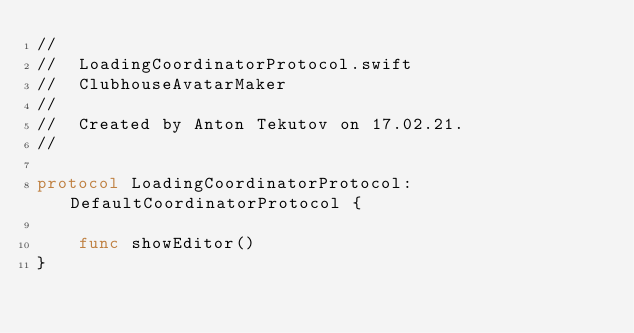Convert code to text. <code><loc_0><loc_0><loc_500><loc_500><_Swift_>//
//  LoadingCoordinatorProtocol.swift
//  ClubhouseAvatarMaker
//
//  Created by Anton Tekutov on 17.02.21.
//

protocol LoadingCoordinatorProtocol: DefaultCoordinatorProtocol {
    
    func showEditor()
}
</code> 